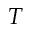<formula> <loc_0><loc_0><loc_500><loc_500>T</formula> 